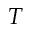<formula> <loc_0><loc_0><loc_500><loc_500>T</formula> 